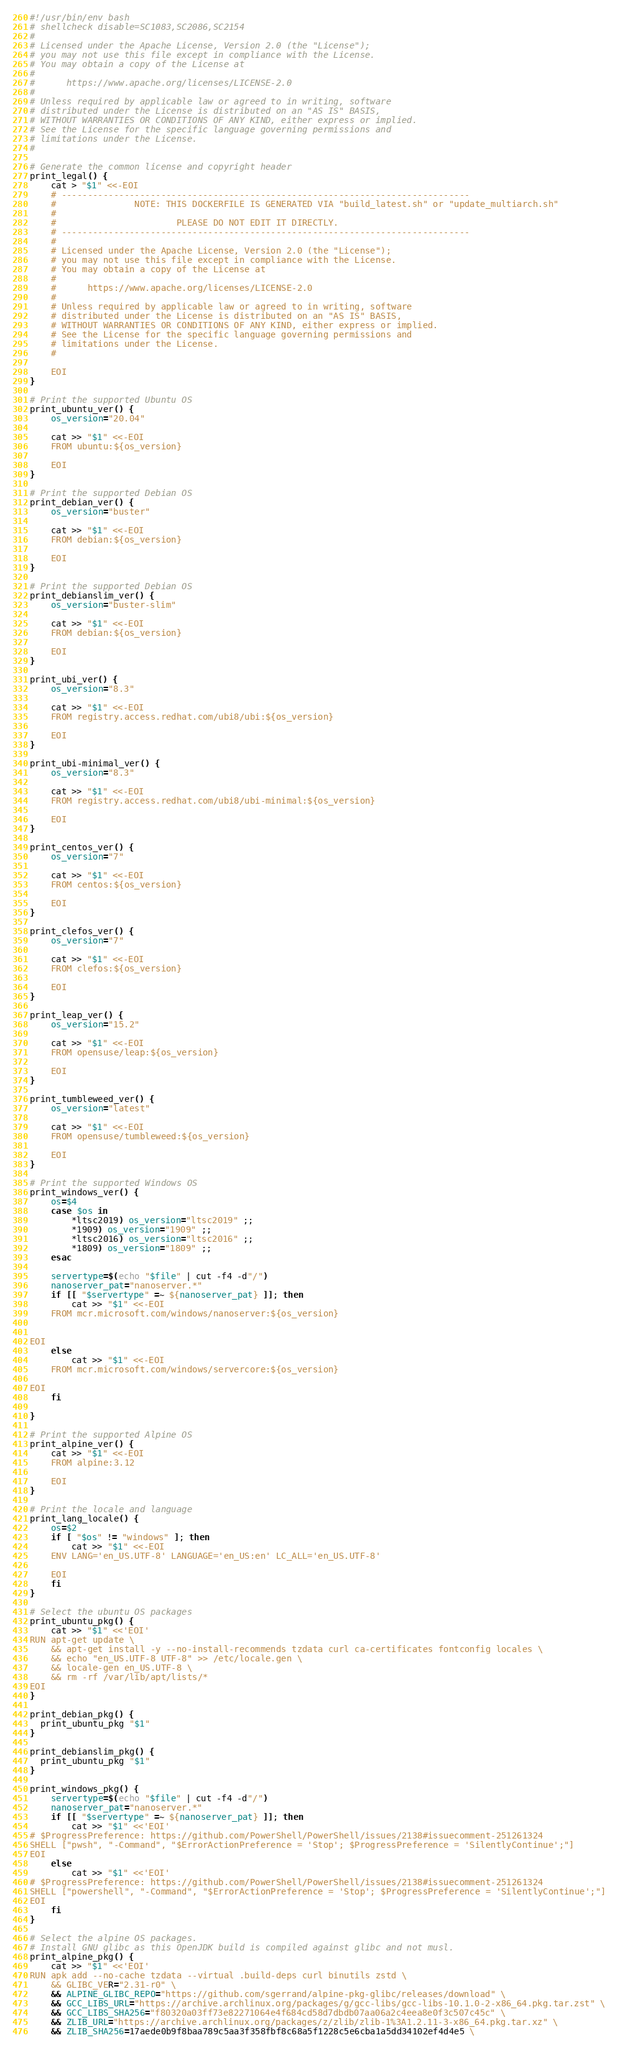Convert code to text. <code><loc_0><loc_0><loc_500><loc_500><_Bash_>#!/usr/bin/env bash
# shellcheck disable=SC1083,SC2086,SC2154
#
# Licensed under the Apache License, Version 2.0 (the "License");
# you may not use this file except in compliance with the License.
# You may obtain a copy of the License at
#
#      https://www.apache.org/licenses/LICENSE-2.0
#
# Unless required by applicable law or agreed to in writing, software
# distributed under the License is distributed on an "AS IS" BASIS,
# WITHOUT WARRANTIES OR CONDITIONS OF ANY KIND, either express or implied.
# See the License for the specific language governing permissions and
# limitations under the License.
#

# Generate the common license and copyright header
print_legal() {
	cat > "$1" <<-EOI
	# ------------------------------------------------------------------------------
	#               NOTE: THIS DOCKERFILE IS GENERATED VIA "build_latest.sh" or "update_multiarch.sh"
	#
	#                       PLEASE DO NOT EDIT IT DIRECTLY.
	# ------------------------------------------------------------------------------
	#
	# Licensed under the Apache License, Version 2.0 (the "License");
	# you may not use this file except in compliance with the License.
	# You may obtain a copy of the License at
	#
	#      https://www.apache.org/licenses/LICENSE-2.0
	#
	# Unless required by applicable law or agreed to in writing, software
	# distributed under the License is distributed on an "AS IS" BASIS,
	# WITHOUT WARRANTIES OR CONDITIONS OF ANY KIND, either express or implied.
	# See the License for the specific language governing permissions and
	# limitations under the License.
	#

	EOI
}

# Print the supported Ubuntu OS
print_ubuntu_ver() {
	os_version="20.04"

	cat >> "$1" <<-EOI
	FROM ubuntu:${os_version}

	EOI
}

# Print the supported Debian OS
print_debian_ver() {
	os_version="buster"

	cat >> "$1" <<-EOI
	FROM debian:${os_version}

	EOI
}

# Print the supported Debian OS
print_debianslim_ver() {
	os_version="buster-slim"

	cat >> "$1" <<-EOI
	FROM debian:${os_version}

	EOI
}

print_ubi_ver() {
	os_version="8.3"

	cat >> "$1" <<-EOI
	FROM registry.access.redhat.com/ubi8/ubi:${os_version}

	EOI
}

print_ubi-minimal_ver() {
	os_version="8.3"

	cat >> "$1" <<-EOI
	FROM registry.access.redhat.com/ubi8/ubi-minimal:${os_version}

	EOI
}

print_centos_ver() {
	os_version="7"

	cat >> "$1" <<-EOI
	FROM centos:${os_version}

	EOI
}

print_clefos_ver() {
	os_version="7"

	cat >> "$1" <<-EOI
	FROM clefos:${os_version}

	EOI
}

print_leap_ver() {
	os_version="15.2"

	cat >> "$1" <<-EOI
	FROM opensuse/leap:${os_version}

	EOI
}

print_tumbleweed_ver() {
	os_version="latest"

	cat >> "$1" <<-EOI
	FROM opensuse/tumbleweed:${os_version}

	EOI
}

# Print the supported Windows OS
print_windows_ver() {
	os=$4
	case $os in
		*ltsc2019) os_version="ltsc2019" ;;
		*1909) os_version="1909" ;;
		*ltsc2016) os_version="ltsc2016" ;;
		*1809) os_version="1809" ;;
	esac

	servertype=$(echo "$file" | cut -f4 -d"/")
	nanoserver_pat="nanoserver.*"
	if [[ "$servertype" =~ ${nanoserver_pat} ]]; then
		cat >> "$1" <<-EOI
	FROM mcr.microsoft.com/windows/nanoserver:${os_version}


EOI
	else
		cat >> "$1" <<-EOI
	FROM mcr.microsoft.com/windows/servercore:${os_version}

EOI
	fi

}

# Print the supported Alpine OS
print_alpine_ver() {
	cat >> "$1" <<-EOI
	FROM alpine:3.12

	EOI
}

# Print the locale and language
print_lang_locale() {
	os=$2
	if [ "$os" != "windows" ]; then
		cat >> "$1" <<-EOI
	ENV LANG='en_US.UTF-8' LANGUAGE='en_US:en' LC_ALL='en_US.UTF-8'

	EOI
	fi
}

# Select the ubuntu OS packages
print_ubuntu_pkg() {
	cat >> "$1" <<'EOI'
RUN apt-get update \
    && apt-get install -y --no-install-recommends tzdata curl ca-certificates fontconfig locales \
    && echo "en_US.UTF-8 UTF-8" >> /etc/locale.gen \
    && locale-gen en_US.UTF-8 \
    && rm -rf /var/lib/apt/lists/*
EOI
}

print_debian_pkg() {
  print_ubuntu_pkg "$1"
}

print_debianslim_pkg() {
  print_ubuntu_pkg "$1"
}

print_windows_pkg() {
	servertype=$(echo "$file" | cut -f4 -d"/")
	nanoserver_pat="nanoserver.*"
	if [[ "$servertype" =~ ${nanoserver_pat} ]]; then
		cat >> "$1" <<'EOI'
# $ProgressPreference: https://github.com/PowerShell/PowerShell/issues/2138#issuecomment-251261324
SHELL ["pwsh", "-Command", "$ErrorActionPreference = 'Stop'; $ProgressPreference = 'SilentlyContinue';"]
EOI
	else
		cat >> "$1" <<'EOI'
# $ProgressPreference: https://github.com/PowerShell/PowerShell/issues/2138#issuecomment-251261324
SHELL ["powershell", "-Command", "$ErrorActionPreference = 'Stop'; $ProgressPreference = 'SilentlyContinue';"]
EOI
	fi
}

# Select the alpine OS packages.
# Install GNU glibc as this OpenJDK build is compiled against glibc and not musl.
print_alpine_pkg() {
	cat >> "$1" <<'EOI'
RUN apk add --no-cache tzdata --virtual .build-deps curl binutils zstd \
    && GLIBC_VER="2.31-r0" \
    && ALPINE_GLIBC_REPO="https://github.com/sgerrand/alpine-pkg-glibc/releases/download" \
    && GCC_LIBS_URL="https://archive.archlinux.org/packages/g/gcc-libs/gcc-libs-10.1.0-2-x86_64.pkg.tar.zst" \
    && GCC_LIBS_SHA256="f80320a03ff73e82271064e4f684cd58d7dbdb07aa06a2c4eea8e0f3c507c45c" \
    && ZLIB_URL="https://archive.archlinux.org/packages/z/zlib/zlib-1%3A1.2.11-3-x86_64.pkg.tar.xz" \
    && ZLIB_SHA256=17aede0b9f8baa789c5aa3f358fbf8c68a5f1228c5e6cba1a5dd34102ef4d4e5 \</code> 